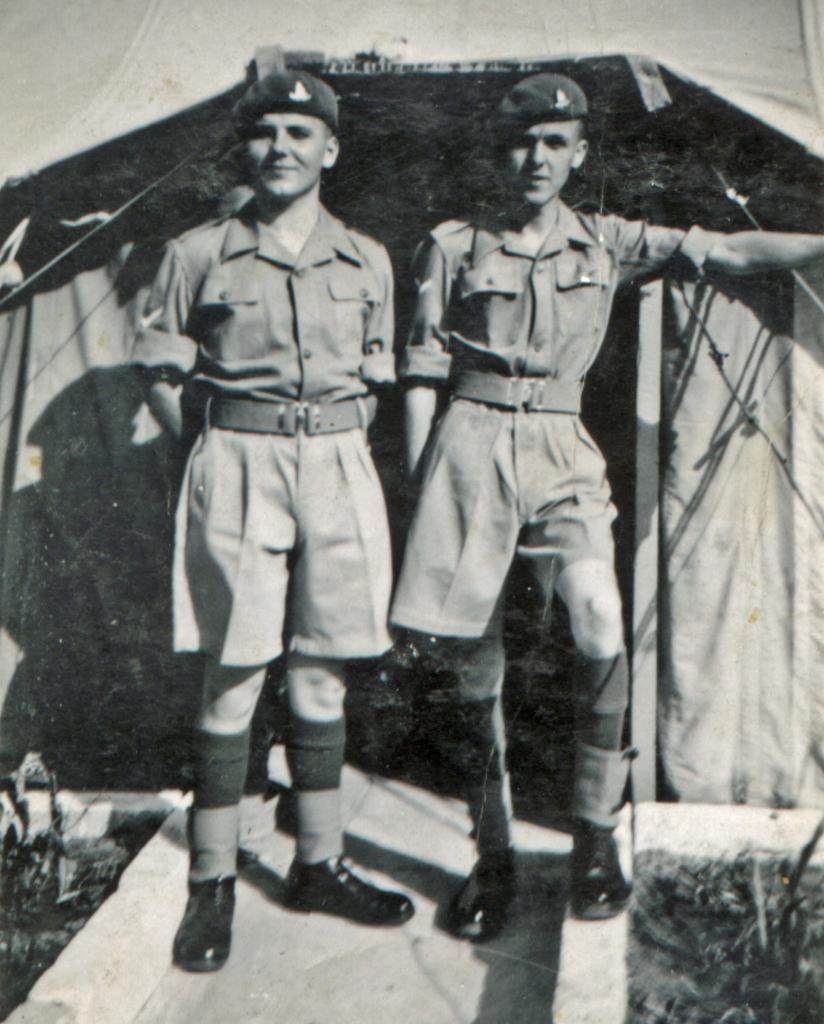How many boys are in the image? There are two boys in the image. What are the boys doing in the image? The boys are standing in the image. What are the boys wearing that is similar? The boys are wearing the same dress. What type of headwear are the boys wearing? The boys are wearing caps. What additional structure can be seen in the image? There is a tent visible in the image. What type of poison is the boys using to stop the parent in the image? There is no poison or parent present in the image, and therefore no such activity can be observed. 